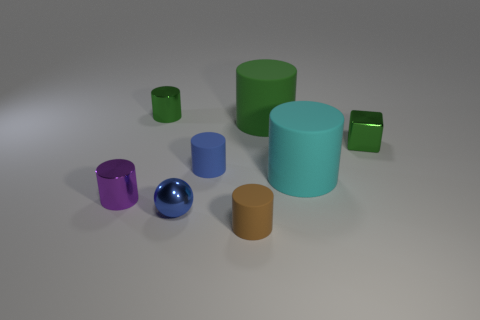Subtract all brown cylinders. How many cylinders are left? 5 Subtract all tiny purple metal cylinders. How many cylinders are left? 5 Subtract all yellow cylinders. Subtract all gray cubes. How many cylinders are left? 6 Add 1 small green rubber balls. How many objects exist? 9 Subtract all cubes. How many objects are left? 7 Subtract all large red shiny objects. Subtract all big cylinders. How many objects are left? 6 Add 5 purple shiny objects. How many purple shiny objects are left? 6 Add 6 large matte cylinders. How many large matte cylinders exist? 8 Subtract 0 purple blocks. How many objects are left? 8 